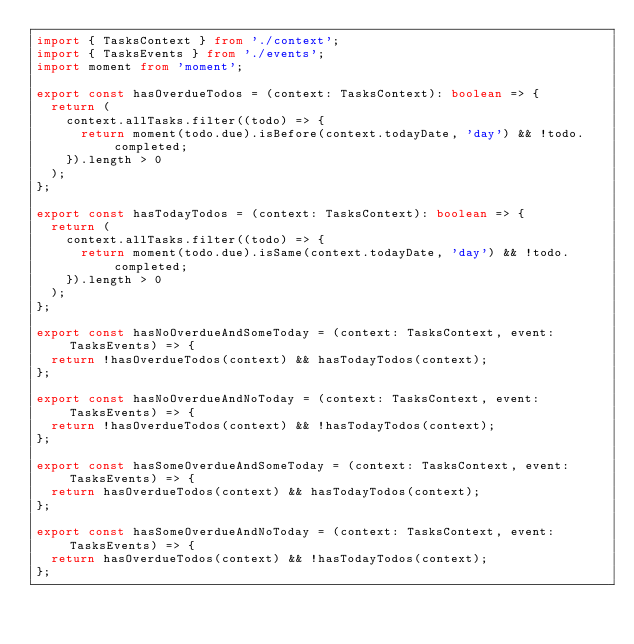Convert code to text. <code><loc_0><loc_0><loc_500><loc_500><_TypeScript_>import { TasksContext } from './context';
import { TasksEvents } from './events';
import moment from 'moment';

export const hasOverdueTodos = (context: TasksContext): boolean => {
  return (
    context.allTasks.filter((todo) => {
      return moment(todo.due).isBefore(context.todayDate, 'day') && !todo.completed;
    }).length > 0
  );
};

export const hasTodayTodos = (context: TasksContext): boolean => {
  return (
    context.allTasks.filter((todo) => {
      return moment(todo.due).isSame(context.todayDate, 'day') && !todo.completed;
    }).length > 0
  );
};

export const hasNoOverdueAndSomeToday = (context: TasksContext, event: TasksEvents) => {
  return !hasOverdueTodos(context) && hasTodayTodos(context);
};

export const hasNoOverdueAndNoToday = (context: TasksContext, event: TasksEvents) => {
  return !hasOverdueTodos(context) && !hasTodayTodos(context);
};

export const hasSomeOverdueAndSomeToday = (context: TasksContext, event: TasksEvents) => {
  return hasOverdueTodos(context) && hasTodayTodos(context);
};

export const hasSomeOverdueAndNoToday = (context: TasksContext, event: TasksEvents) => {
  return hasOverdueTodos(context) && !hasTodayTodos(context);
};
</code> 